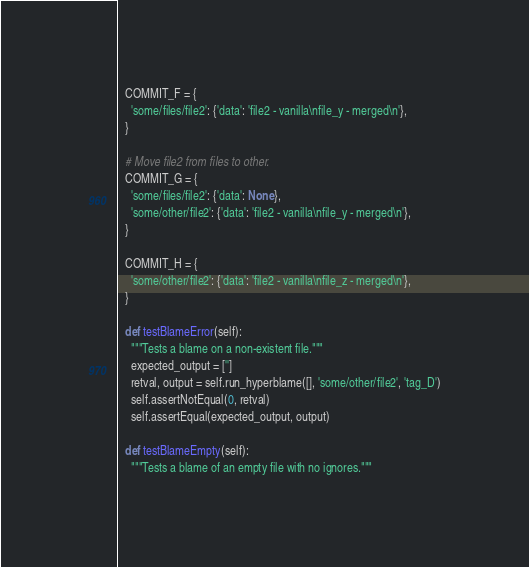<code> <loc_0><loc_0><loc_500><loc_500><_Python_>
  COMMIT_F = {
    'some/files/file2': {'data': 'file2 - vanilla\nfile_y - merged\n'},
  }

  # Move file2 from files to other.
  COMMIT_G = {
    'some/files/file2': {'data': None},
    'some/other/file2': {'data': 'file2 - vanilla\nfile_y - merged\n'},
  }

  COMMIT_H = {
    'some/other/file2': {'data': 'file2 - vanilla\nfile_z - merged\n'},
  }

  def testBlameError(self):
    """Tests a blame on a non-existent file."""
    expected_output = ['']
    retval, output = self.run_hyperblame([], 'some/other/file2', 'tag_D')
    self.assertNotEqual(0, retval)
    self.assertEqual(expected_output, output)

  def testBlameEmpty(self):
    """Tests a blame of an empty file with no ignores."""</code> 